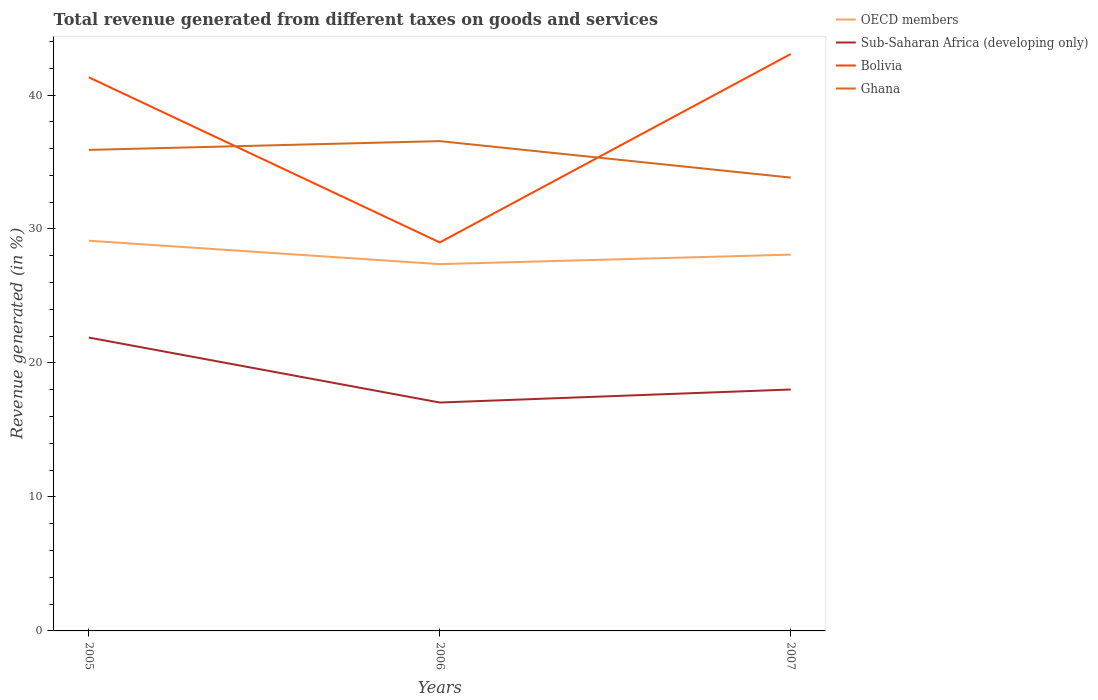How many different coloured lines are there?
Offer a terse response. 4. Across all years, what is the maximum total revenue generated in OECD members?
Keep it short and to the point. 27.38. In which year was the total revenue generated in Bolivia maximum?
Make the answer very short. 2006. What is the total total revenue generated in Bolivia in the graph?
Ensure brevity in your answer.  -14.06. What is the difference between the highest and the second highest total revenue generated in OECD members?
Provide a succinct answer. 1.75. What is the difference between the highest and the lowest total revenue generated in Sub-Saharan Africa (developing only)?
Offer a terse response. 1. Is the total revenue generated in OECD members strictly greater than the total revenue generated in Ghana over the years?
Make the answer very short. Yes. How many lines are there?
Your response must be concise. 4. How many years are there in the graph?
Your answer should be compact. 3. What is the difference between two consecutive major ticks on the Y-axis?
Your answer should be very brief. 10. Are the values on the major ticks of Y-axis written in scientific E-notation?
Provide a succinct answer. No. Does the graph contain grids?
Provide a short and direct response. No. Where does the legend appear in the graph?
Your response must be concise. Top right. What is the title of the graph?
Provide a short and direct response. Total revenue generated from different taxes on goods and services. Does "Belize" appear as one of the legend labels in the graph?
Offer a terse response. No. What is the label or title of the Y-axis?
Provide a short and direct response. Revenue generated (in %). What is the Revenue generated (in %) in OECD members in 2005?
Your answer should be very brief. 29.13. What is the Revenue generated (in %) of Sub-Saharan Africa (developing only) in 2005?
Ensure brevity in your answer.  21.9. What is the Revenue generated (in %) of Bolivia in 2005?
Provide a short and direct response. 41.32. What is the Revenue generated (in %) of Ghana in 2005?
Your response must be concise. 35.9. What is the Revenue generated (in %) in OECD members in 2006?
Provide a succinct answer. 27.38. What is the Revenue generated (in %) of Sub-Saharan Africa (developing only) in 2006?
Keep it short and to the point. 17.05. What is the Revenue generated (in %) in Bolivia in 2006?
Offer a terse response. 29. What is the Revenue generated (in %) in Ghana in 2006?
Ensure brevity in your answer.  36.56. What is the Revenue generated (in %) of OECD members in 2007?
Ensure brevity in your answer.  28.08. What is the Revenue generated (in %) of Sub-Saharan Africa (developing only) in 2007?
Make the answer very short. 18.02. What is the Revenue generated (in %) in Bolivia in 2007?
Provide a short and direct response. 43.06. What is the Revenue generated (in %) in Ghana in 2007?
Make the answer very short. 33.84. Across all years, what is the maximum Revenue generated (in %) of OECD members?
Your response must be concise. 29.13. Across all years, what is the maximum Revenue generated (in %) of Sub-Saharan Africa (developing only)?
Keep it short and to the point. 21.9. Across all years, what is the maximum Revenue generated (in %) in Bolivia?
Your answer should be compact. 43.06. Across all years, what is the maximum Revenue generated (in %) in Ghana?
Your response must be concise. 36.56. Across all years, what is the minimum Revenue generated (in %) in OECD members?
Your answer should be compact. 27.38. Across all years, what is the minimum Revenue generated (in %) in Sub-Saharan Africa (developing only)?
Your answer should be compact. 17.05. Across all years, what is the minimum Revenue generated (in %) in Bolivia?
Keep it short and to the point. 29. Across all years, what is the minimum Revenue generated (in %) of Ghana?
Offer a terse response. 33.84. What is the total Revenue generated (in %) in OECD members in the graph?
Offer a terse response. 84.59. What is the total Revenue generated (in %) in Sub-Saharan Africa (developing only) in the graph?
Your response must be concise. 56.97. What is the total Revenue generated (in %) of Bolivia in the graph?
Make the answer very short. 113.38. What is the total Revenue generated (in %) of Ghana in the graph?
Provide a short and direct response. 106.3. What is the difference between the Revenue generated (in %) in OECD members in 2005 and that in 2006?
Offer a terse response. 1.75. What is the difference between the Revenue generated (in %) in Sub-Saharan Africa (developing only) in 2005 and that in 2006?
Offer a terse response. 4.85. What is the difference between the Revenue generated (in %) in Bolivia in 2005 and that in 2006?
Keep it short and to the point. 12.32. What is the difference between the Revenue generated (in %) of Ghana in 2005 and that in 2006?
Your response must be concise. -0.66. What is the difference between the Revenue generated (in %) in OECD members in 2005 and that in 2007?
Offer a very short reply. 1.04. What is the difference between the Revenue generated (in %) of Sub-Saharan Africa (developing only) in 2005 and that in 2007?
Give a very brief answer. 3.88. What is the difference between the Revenue generated (in %) of Bolivia in 2005 and that in 2007?
Make the answer very short. -1.74. What is the difference between the Revenue generated (in %) in Ghana in 2005 and that in 2007?
Ensure brevity in your answer.  2.07. What is the difference between the Revenue generated (in %) in OECD members in 2006 and that in 2007?
Your answer should be very brief. -0.71. What is the difference between the Revenue generated (in %) in Sub-Saharan Africa (developing only) in 2006 and that in 2007?
Your answer should be compact. -0.97. What is the difference between the Revenue generated (in %) of Bolivia in 2006 and that in 2007?
Ensure brevity in your answer.  -14.06. What is the difference between the Revenue generated (in %) of Ghana in 2006 and that in 2007?
Your answer should be very brief. 2.72. What is the difference between the Revenue generated (in %) in OECD members in 2005 and the Revenue generated (in %) in Sub-Saharan Africa (developing only) in 2006?
Offer a terse response. 12.08. What is the difference between the Revenue generated (in %) in OECD members in 2005 and the Revenue generated (in %) in Bolivia in 2006?
Your response must be concise. 0.13. What is the difference between the Revenue generated (in %) of OECD members in 2005 and the Revenue generated (in %) of Ghana in 2006?
Offer a terse response. -7.43. What is the difference between the Revenue generated (in %) of Sub-Saharan Africa (developing only) in 2005 and the Revenue generated (in %) of Bolivia in 2006?
Your response must be concise. -7.1. What is the difference between the Revenue generated (in %) in Sub-Saharan Africa (developing only) in 2005 and the Revenue generated (in %) in Ghana in 2006?
Provide a succinct answer. -14.66. What is the difference between the Revenue generated (in %) of Bolivia in 2005 and the Revenue generated (in %) of Ghana in 2006?
Give a very brief answer. 4.76. What is the difference between the Revenue generated (in %) of OECD members in 2005 and the Revenue generated (in %) of Sub-Saharan Africa (developing only) in 2007?
Give a very brief answer. 11.11. What is the difference between the Revenue generated (in %) in OECD members in 2005 and the Revenue generated (in %) in Bolivia in 2007?
Provide a succinct answer. -13.94. What is the difference between the Revenue generated (in %) in OECD members in 2005 and the Revenue generated (in %) in Ghana in 2007?
Your response must be concise. -4.71. What is the difference between the Revenue generated (in %) in Sub-Saharan Africa (developing only) in 2005 and the Revenue generated (in %) in Bolivia in 2007?
Ensure brevity in your answer.  -21.16. What is the difference between the Revenue generated (in %) in Sub-Saharan Africa (developing only) in 2005 and the Revenue generated (in %) in Ghana in 2007?
Your answer should be compact. -11.94. What is the difference between the Revenue generated (in %) in Bolivia in 2005 and the Revenue generated (in %) in Ghana in 2007?
Provide a succinct answer. 7.49. What is the difference between the Revenue generated (in %) in OECD members in 2006 and the Revenue generated (in %) in Sub-Saharan Africa (developing only) in 2007?
Offer a very short reply. 9.36. What is the difference between the Revenue generated (in %) of OECD members in 2006 and the Revenue generated (in %) of Bolivia in 2007?
Your answer should be very brief. -15.68. What is the difference between the Revenue generated (in %) of OECD members in 2006 and the Revenue generated (in %) of Ghana in 2007?
Your response must be concise. -6.46. What is the difference between the Revenue generated (in %) of Sub-Saharan Africa (developing only) in 2006 and the Revenue generated (in %) of Bolivia in 2007?
Your answer should be very brief. -26.01. What is the difference between the Revenue generated (in %) of Sub-Saharan Africa (developing only) in 2006 and the Revenue generated (in %) of Ghana in 2007?
Offer a very short reply. -16.79. What is the difference between the Revenue generated (in %) in Bolivia in 2006 and the Revenue generated (in %) in Ghana in 2007?
Provide a short and direct response. -4.84. What is the average Revenue generated (in %) in OECD members per year?
Ensure brevity in your answer.  28.2. What is the average Revenue generated (in %) of Sub-Saharan Africa (developing only) per year?
Make the answer very short. 18.99. What is the average Revenue generated (in %) of Bolivia per year?
Offer a terse response. 37.79. What is the average Revenue generated (in %) in Ghana per year?
Make the answer very short. 35.43. In the year 2005, what is the difference between the Revenue generated (in %) of OECD members and Revenue generated (in %) of Sub-Saharan Africa (developing only)?
Your answer should be compact. 7.23. In the year 2005, what is the difference between the Revenue generated (in %) in OECD members and Revenue generated (in %) in Bolivia?
Offer a very short reply. -12.2. In the year 2005, what is the difference between the Revenue generated (in %) in OECD members and Revenue generated (in %) in Ghana?
Ensure brevity in your answer.  -6.78. In the year 2005, what is the difference between the Revenue generated (in %) of Sub-Saharan Africa (developing only) and Revenue generated (in %) of Bolivia?
Offer a terse response. -19.43. In the year 2005, what is the difference between the Revenue generated (in %) in Sub-Saharan Africa (developing only) and Revenue generated (in %) in Ghana?
Your response must be concise. -14.01. In the year 2005, what is the difference between the Revenue generated (in %) in Bolivia and Revenue generated (in %) in Ghana?
Offer a very short reply. 5.42. In the year 2006, what is the difference between the Revenue generated (in %) of OECD members and Revenue generated (in %) of Sub-Saharan Africa (developing only)?
Offer a terse response. 10.33. In the year 2006, what is the difference between the Revenue generated (in %) of OECD members and Revenue generated (in %) of Bolivia?
Offer a terse response. -1.62. In the year 2006, what is the difference between the Revenue generated (in %) of OECD members and Revenue generated (in %) of Ghana?
Your response must be concise. -9.18. In the year 2006, what is the difference between the Revenue generated (in %) in Sub-Saharan Africa (developing only) and Revenue generated (in %) in Bolivia?
Your answer should be compact. -11.95. In the year 2006, what is the difference between the Revenue generated (in %) in Sub-Saharan Africa (developing only) and Revenue generated (in %) in Ghana?
Your answer should be compact. -19.51. In the year 2006, what is the difference between the Revenue generated (in %) in Bolivia and Revenue generated (in %) in Ghana?
Ensure brevity in your answer.  -7.56. In the year 2007, what is the difference between the Revenue generated (in %) in OECD members and Revenue generated (in %) in Sub-Saharan Africa (developing only)?
Keep it short and to the point. 10.06. In the year 2007, what is the difference between the Revenue generated (in %) of OECD members and Revenue generated (in %) of Bolivia?
Make the answer very short. -14.98. In the year 2007, what is the difference between the Revenue generated (in %) of OECD members and Revenue generated (in %) of Ghana?
Provide a short and direct response. -5.75. In the year 2007, what is the difference between the Revenue generated (in %) of Sub-Saharan Africa (developing only) and Revenue generated (in %) of Bolivia?
Your answer should be very brief. -25.04. In the year 2007, what is the difference between the Revenue generated (in %) of Sub-Saharan Africa (developing only) and Revenue generated (in %) of Ghana?
Your answer should be compact. -15.82. In the year 2007, what is the difference between the Revenue generated (in %) of Bolivia and Revenue generated (in %) of Ghana?
Your answer should be compact. 9.22. What is the ratio of the Revenue generated (in %) in OECD members in 2005 to that in 2006?
Offer a very short reply. 1.06. What is the ratio of the Revenue generated (in %) of Sub-Saharan Africa (developing only) in 2005 to that in 2006?
Offer a very short reply. 1.28. What is the ratio of the Revenue generated (in %) of Bolivia in 2005 to that in 2006?
Keep it short and to the point. 1.43. What is the ratio of the Revenue generated (in %) in Ghana in 2005 to that in 2006?
Your response must be concise. 0.98. What is the ratio of the Revenue generated (in %) of OECD members in 2005 to that in 2007?
Your answer should be compact. 1.04. What is the ratio of the Revenue generated (in %) in Sub-Saharan Africa (developing only) in 2005 to that in 2007?
Give a very brief answer. 1.22. What is the ratio of the Revenue generated (in %) in Bolivia in 2005 to that in 2007?
Offer a very short reply. 0.96. What is the ratio of the Revenue generated (in %) of Ghana in 2005 to that in 2007?
Make the answer very short. 1.06. What is the ratio of the Revenue generated (in %) of OECD members in 2006 to that in 2007?
Ensure brevity in your answer.  0.97. What is the ratio of the Revenue generated (in %) in Sub-Saharan Africa (developing only) in 2006 to that in 2007?
Your response must be concise. 0.95. What is the ratio of the Revenue generated (in %) of Bolivia in 2006 to that in 2007?
Your answer should be compact. 0.67. What is the ratio of the Revenue generated (in %) of Ghana in 2006 to that in 2007?
Provide a short and direct response. 1.08. What is the difference between the highest and the second highest Revenue generated (in %) in OECD members?
Your answer should be very brief. 1.04. What is the difference between the highest and the second highest Revenue generated (in %) in Sub-Saharan Africa (developing only)?
Your answer should be compact. 3.88. What is the difference between the highest and the second highest Revenue generated (in %) in Bolivia?
Your response must be concise. 1.74. What is the difference between the highest and the second highest Revenue generated (in %) in Ghana?
Keep it short and to the point. 0.66. What is the difference between the highest and the lowest Revenue generated (in %) in OECD members?
Offer a terse response. 1.75. What is the difference between the highest and the lowest Revenue generated (in %) in Sub-Saharan Africa (developing only)?
Make the answer very short. 4.85. What is the difference between the highest and the lowest Revenue generated (in %) of Bolivia?
Make the answer very short. 14.06. What is the difference between the highest and the lowest Revenue generated (in %) of Ghana?
Provide a succinct answer. 2.72. 